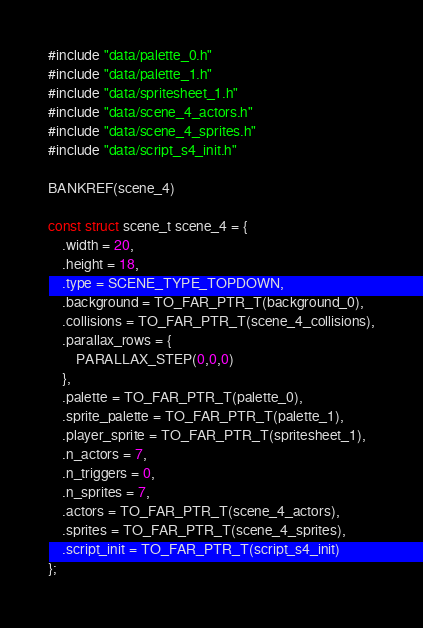Convert code to text. <code><loc_0><loc_0><loc_500><loc_500><_C_>#include "data/palette_0.h"
#include "data/palette_1.h"
#include "data/spritesheet_1.h"
#include "data/scene_4_actors.h"
#include "data/scene_4_sprites.h"
#include "data/script_s4_init.h"

BANKREF(scene_4)

const struct scene_t scene_4 = {
    .width = 20,
    .height = 18,
    .type = SCENE_TYPE_TOPDOWN,
    .background = TO_FAR_PTR_T(background_0),
    .collisions = TO_FAR_PTR_T(scene_4_collisions),
    .parallax_rows = {
        PARALLAX_STEP(0,0,0)
    },
    .palette = TO_FAR_PTR_T(palette_0),
    .sprite_palette = TO_FAR_PTR_T(palette_1),
    .player_sprite = TO_FAR_PTR_T(spritesheet_1),
    .n_actors = 7,
    .n_triggers = 0,
    .n_sprites = 7,
    .actors = TO_FAR_PTR_T(scene_4_actors),
    .sprites = TO_FAR_PTR_T(scene_4_sprites),
    .script_init = TO_FAR_PTR_T(script_s4_init)
};
</code> 